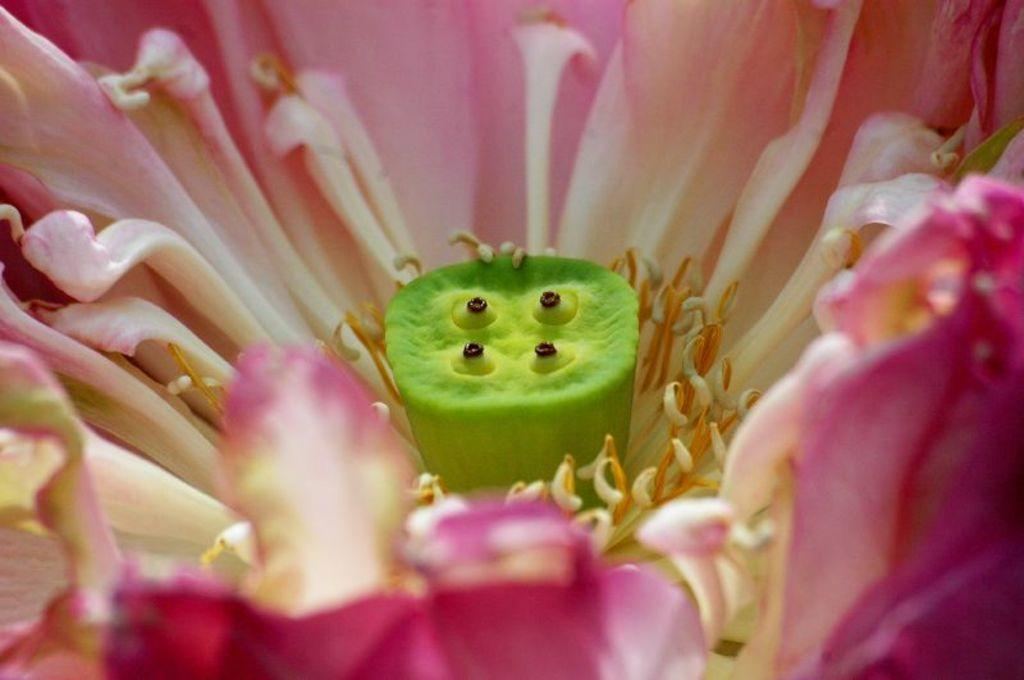What is the main subject of the image? There is a flower in the image. Can you describe the color of the flower? The flower is pale pink in color. What can be seen on the flower? Pollen grains are visible on the flower. What type of plate is being used to hold the straw in the image? There is no plate or straw present in the image; it only features a flower with pollen grains. 